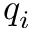Convert formula to latex. <formula><loc_0><loc_0><loc_500><loc_500>q _ { i }</formula> 